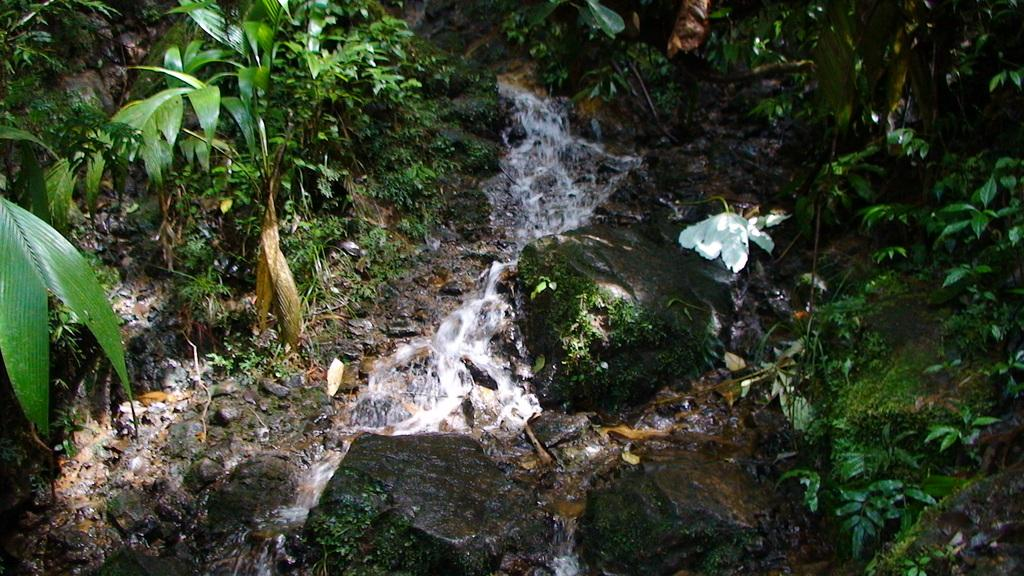Where was the picture taken? The picture was taken outside. What can be seen in the center of the image? There is running water in the center of the image. What type of natural features are visible in the image? Rocks and plants are present in the image. What is the color of the grass in the image? Green grass is visible in the image. Can you describe any other items in the image? There are other unspecified items in the image. How many brothers are standing near the running water in the image? There is no mention of brothers or any people in the image; it only features natural elements such as water, rocks, plants, and grass. 